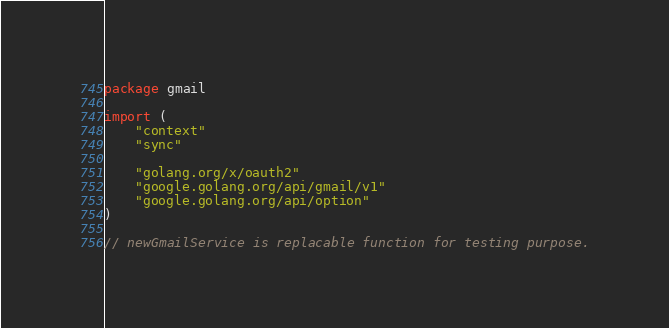Convert code to text. <code><loc_0><loc_0><loc_500><loc_500><_Go_>package gmail

import (
	"context"
	"sync"

	"golang.org/x/oauth2"
	"google.golang.org/api/gmail/v1"
	"google.golang.org/api/option"
)

// newGmailService is replacable function for testing purpose.</code> 